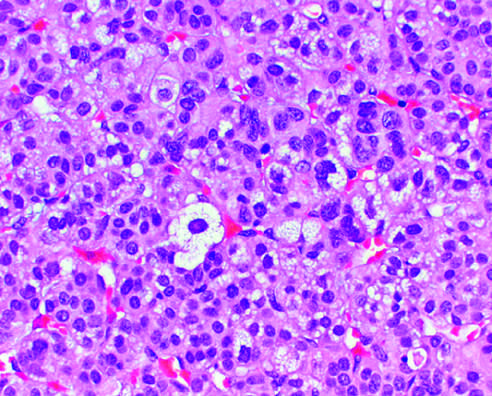s there mild nuclear pleomorphism?
Answer the question using a single word or phrase. Yes 